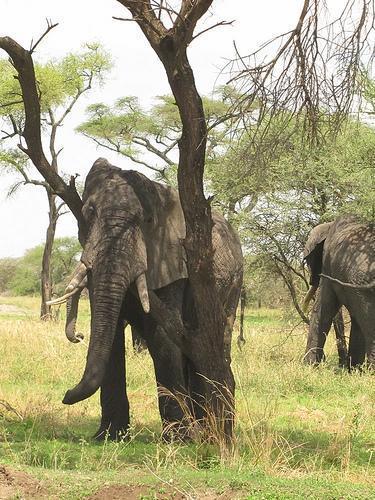How many elephant trunks can you see in the picture?
Give a very brief answer. 3. 